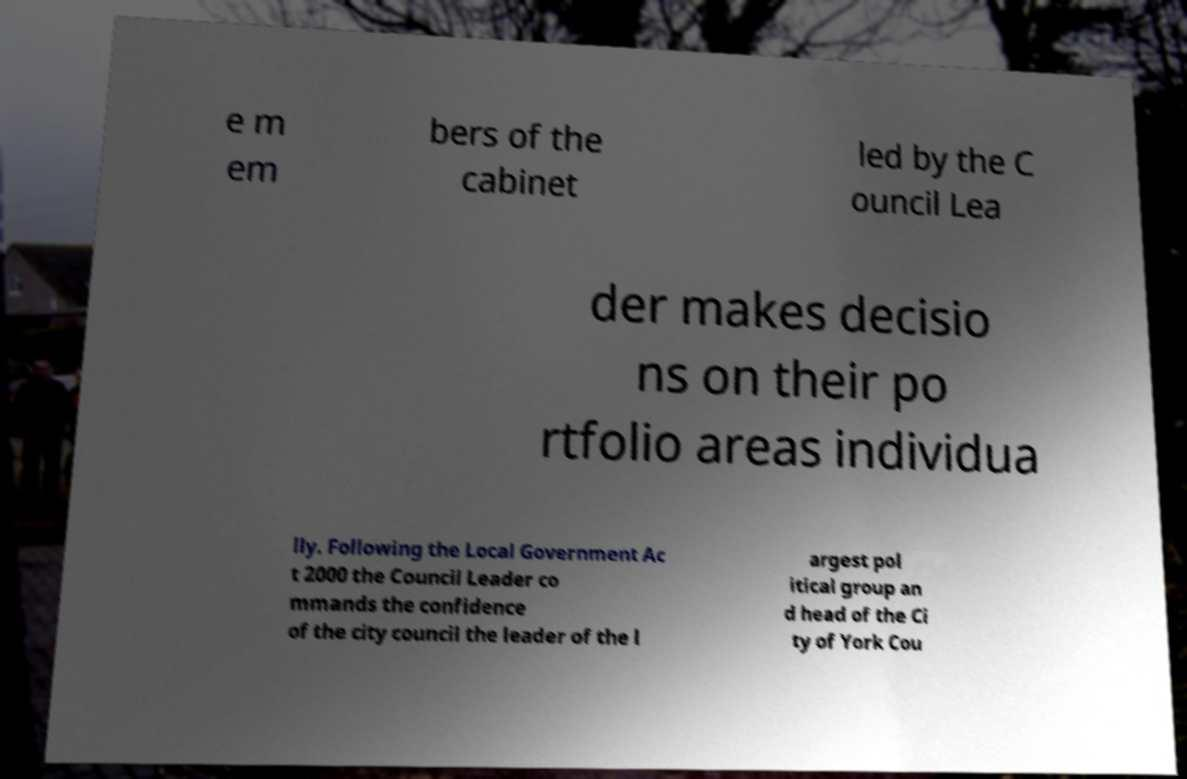For documentation purposes, I need the text within this image transcribed. Could you provide that? e m em bers of the cabinet led by the C ouncil Lea der makes decisio ns on their po rtfolio areas individua lly. Following the Local Government Ac t 2000 the Council Leader co mmands the confidence of the city council the leader of the l argest pol itical group an d head of the Ci ty of York Cou 